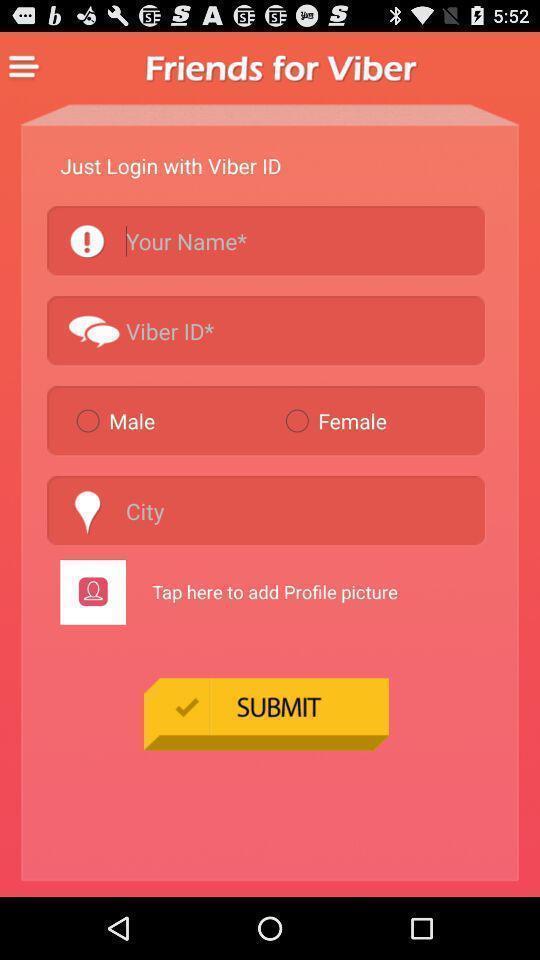Describe this image in words. Page requesting to enter details on an app. 